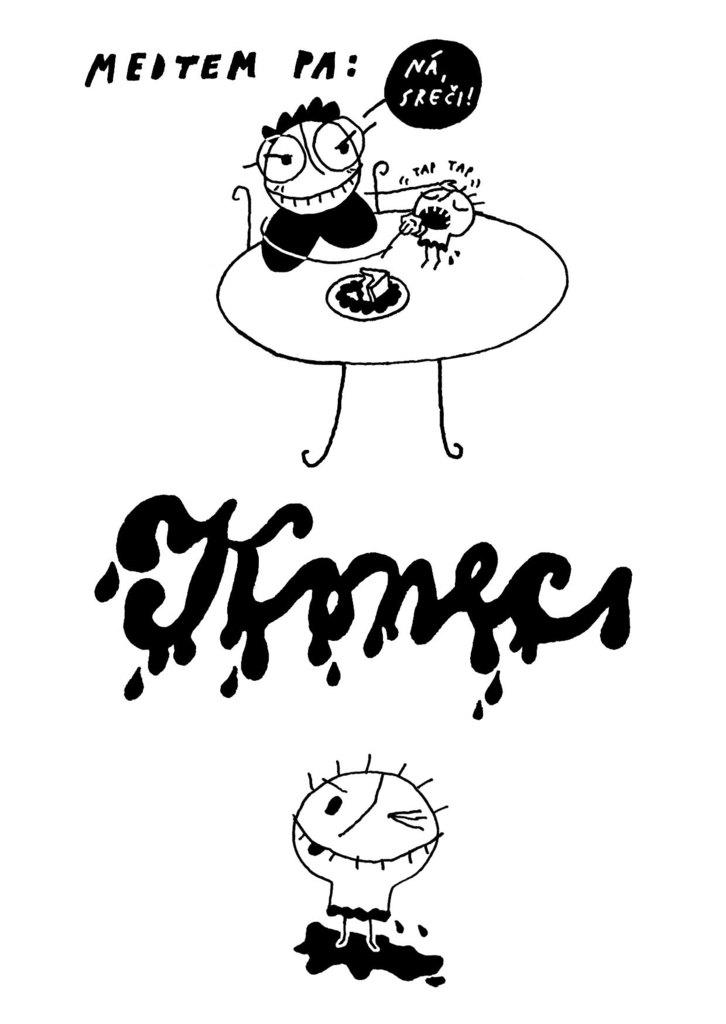What type of images can be seen in the picture? There are images of cartoons in the image. Can you describe any additional features of the image? Yes, there is edited text in the image. How many hands are visible in the image? There are no hands visible in the image; it only contains cartoon images and edited text. 